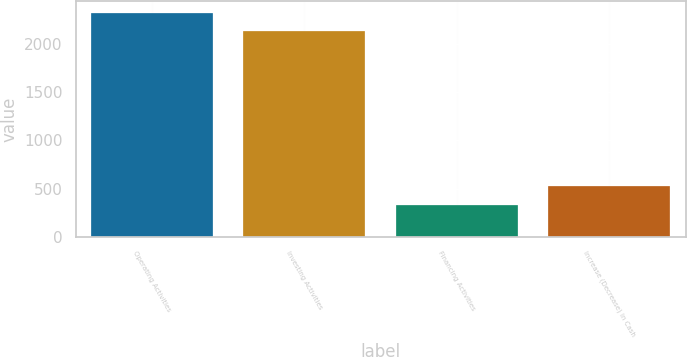<chart> <loc_0><loc_0><loc_500><loc_500><bar_chart><fcel>Operating Activities<fcel>Investing Activities<fcel>Financing Activities<fcel>Increase (Decrease) in Cash<nl><fcel>2327.8<fcel>2132<fcel>327<fcel>522.8<nl></chart> 